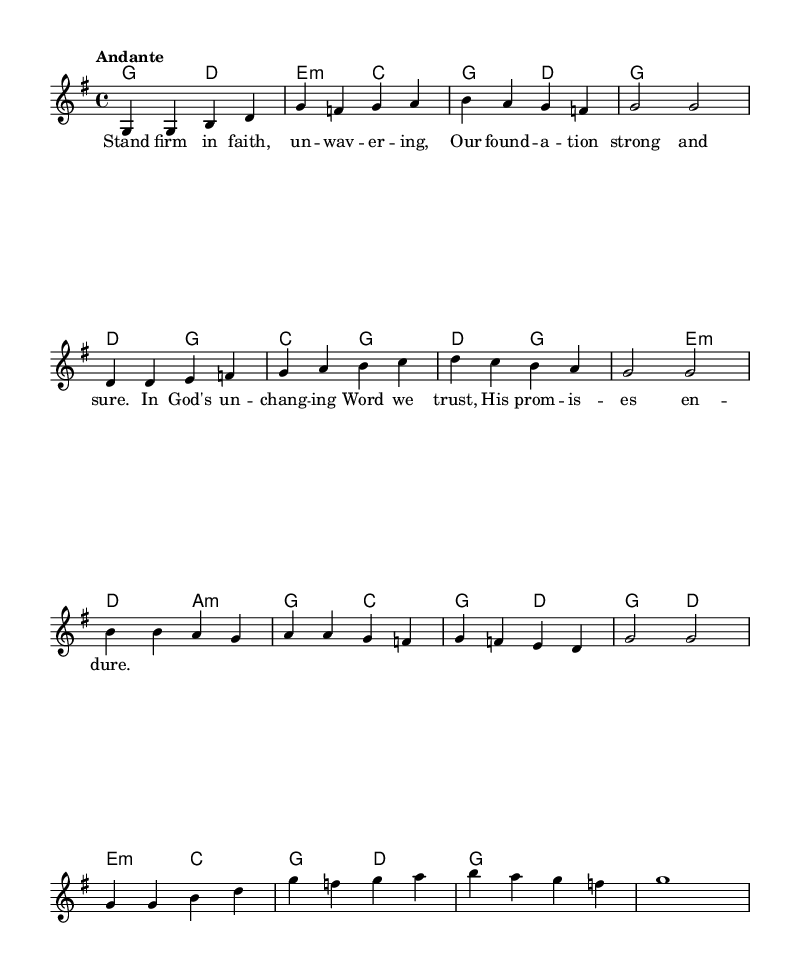What is the key signature of this music? The key signature is G major, which has one sharp (F#).
Answer: G major What is the time signature of this music? The time signature is 4/4, meaning there are four beats in each measure.
Answer: 4/4 What is the tempo marking of this music? The tempo marking is Andante, indicating a moderately slow tempo.
Answer: Andante How many measures are in the melody? The melody contains a total of 8 measures, as indicated by the notation in the first and last lines.
Answer: 8 measures What does the first line of lyrics suggest about the message of the hymn? The first line emphasizes the theme of faith and steadfastness, typical of religious hymns.
Answer: Faith and steadfastness What harmonic structure is used in the third section of the piece? The third section uses a combination of tonic (G), subdominant (C), and dominant (D) chords, which is common in religious music for stability.
Answer: Tonic, subdominant, dominant What is the phrase length of the melody? The melody displays a phrase length of two measures at a time, creating a balanced structure.
Answer: Two measures 